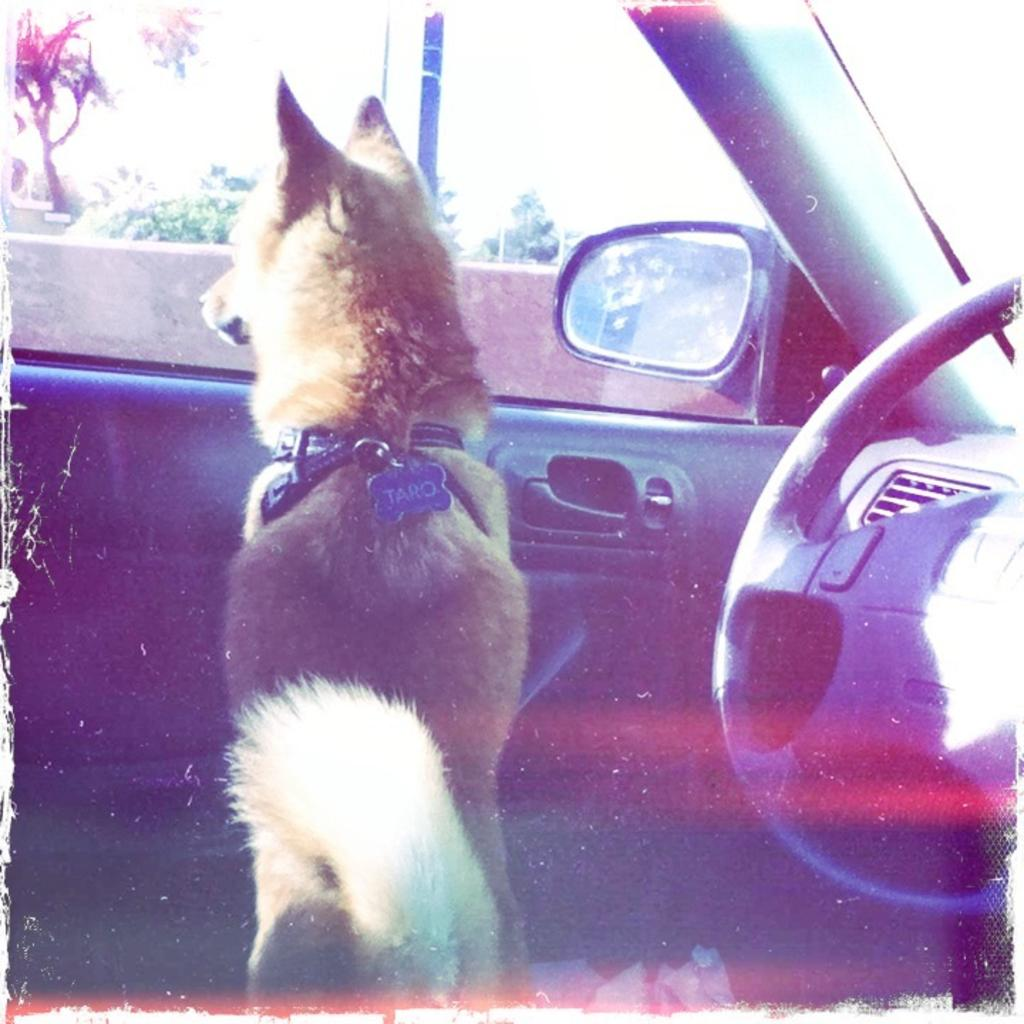What animal is inside the car in the image? There is a dog inside the car in the image. What is used to control the car's direction? The car has a steering wheel. How can someone enter or exit the car? The car has a door handle. What is used to check the surroundings while driving? The car has a mirror. What can be seen outside the car through the glass window? There is an outside view visible through the car's glass window, and trees are visible through it. What type of plate is being used to rub the dog's fur in the image? There is no plate or rubbing of the dog's fur present in the image. 